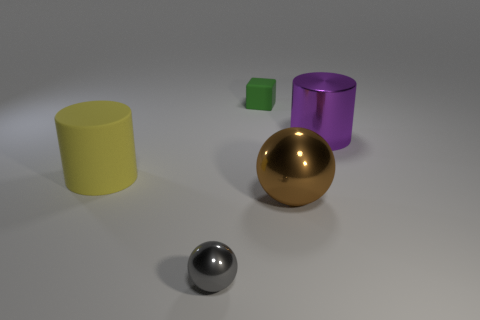How many other objects are there of the same color as the cube?
Your answer should be compact. 0. Is there anything else that has the same size as the green rubber block?
Offer a very short reply. Yes. Do the rubber thing behind the purple thing and the big purple cylinder have the same size?
Offer a terse response. No. There is a small object on the right side of the small sphere; what is it made of?
Your answer should be very brief. Rubber. Is there anything else that is the same shape as the small green thing?
Offer a terse response. No. How many shiny things are either tiny things or cyan cylinders?
Give a very brief answer. 1. Are there fewer big yellow rubber cylinders that are right of the green object than red cylinders?
Provide a succinct answer. No. What shape is the tiny object behind the metal sphere that is to the right of the sphere that is left of the tiny green object?
Your answer should be very brief. Cube. Do the cube and the small ball have the same color?
Ensure brevity in your answer.  No. Is the number of yellow rubber objects greater than the number of tiny purple matte cubes?
Offer a very short reply. Yes. 